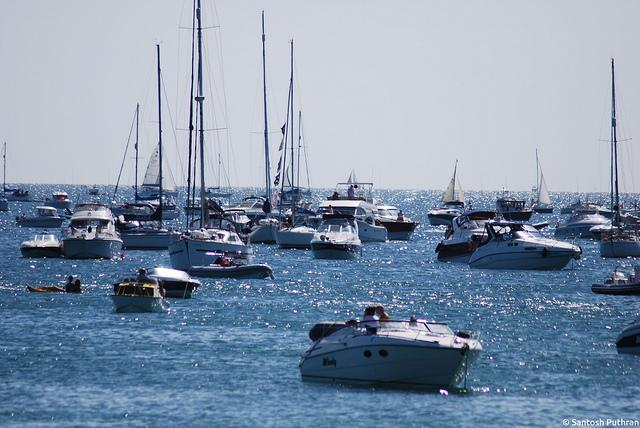Why do some boats have a big pole sticking up from it?

Choices:
A) for sails
B) for navigation
C) send sos
D) for lookout for sails 